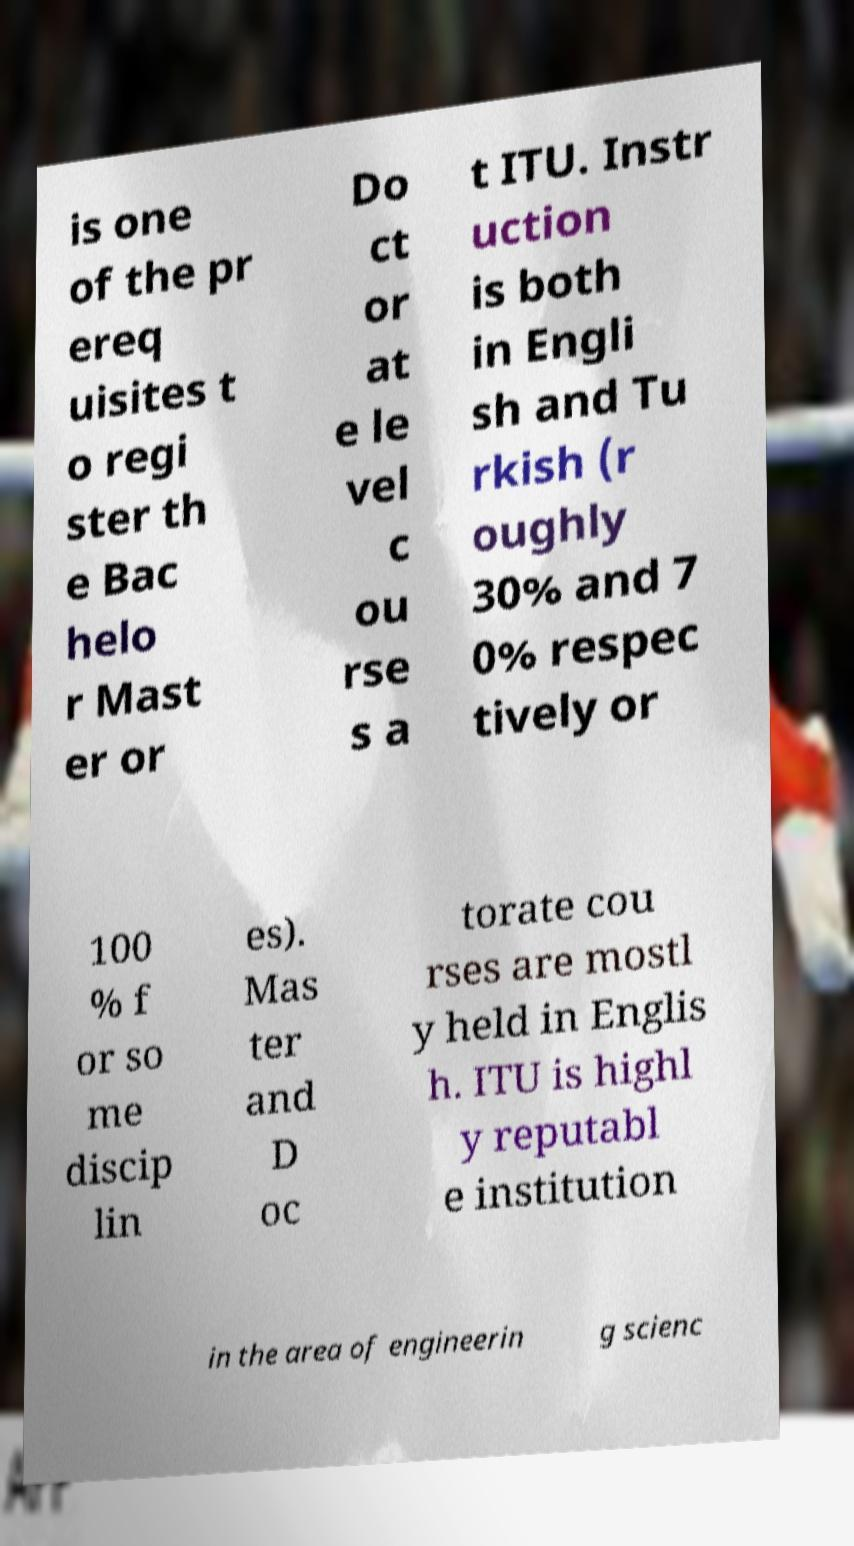Can you read and provide the text displayed in the image?This photo seems to have some interesting text. Can you extract and type it out for me? is one of the pr ereq uisites t o regi ster th e Bac helo r Mast er or Do ct or at e le vel c ou rse s a t ITU. Instr uction is both in Engli sh and Tu rkish (r oughly 30% and 7 0% respec tively or 100 % f or so me discip lin es). Mas ter and D oc torate cou rses are mostl y held in Englis h. ITU is highl y reputabl e institution in the area of engineerin g scienc 